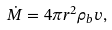Convert formula to latex. <formula><loc_0><loc_0><loc_500><loc_500>\dot { M } = 4 \pi r ^ { 2 } \rho _ { b } v ,</formula> 